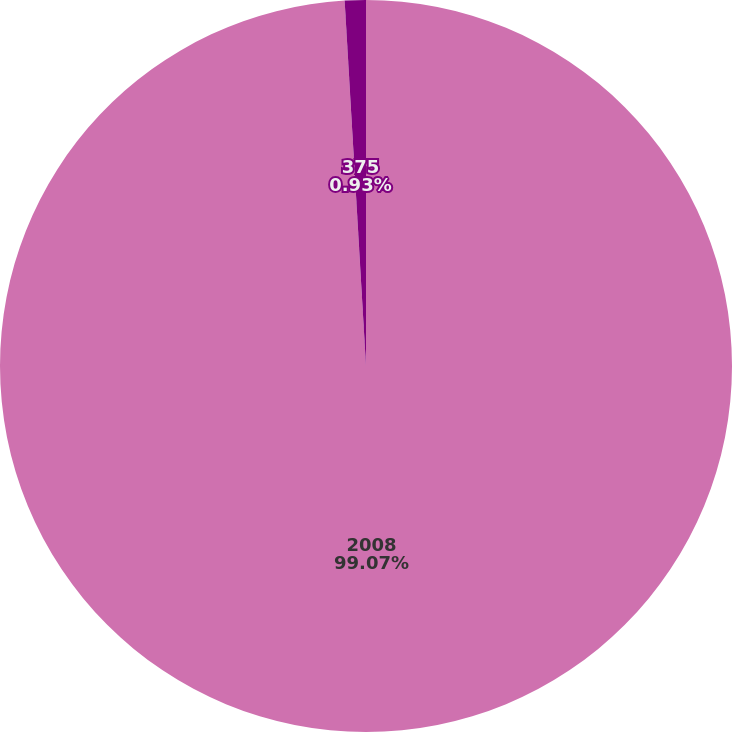Convert chart. <chart><loc_0><loc_0><loc_500><loc_500><pie_chart><fcel>2008<fcel>375<nl><fcel>99.07%<fcel>0.93%<nl></chart> 